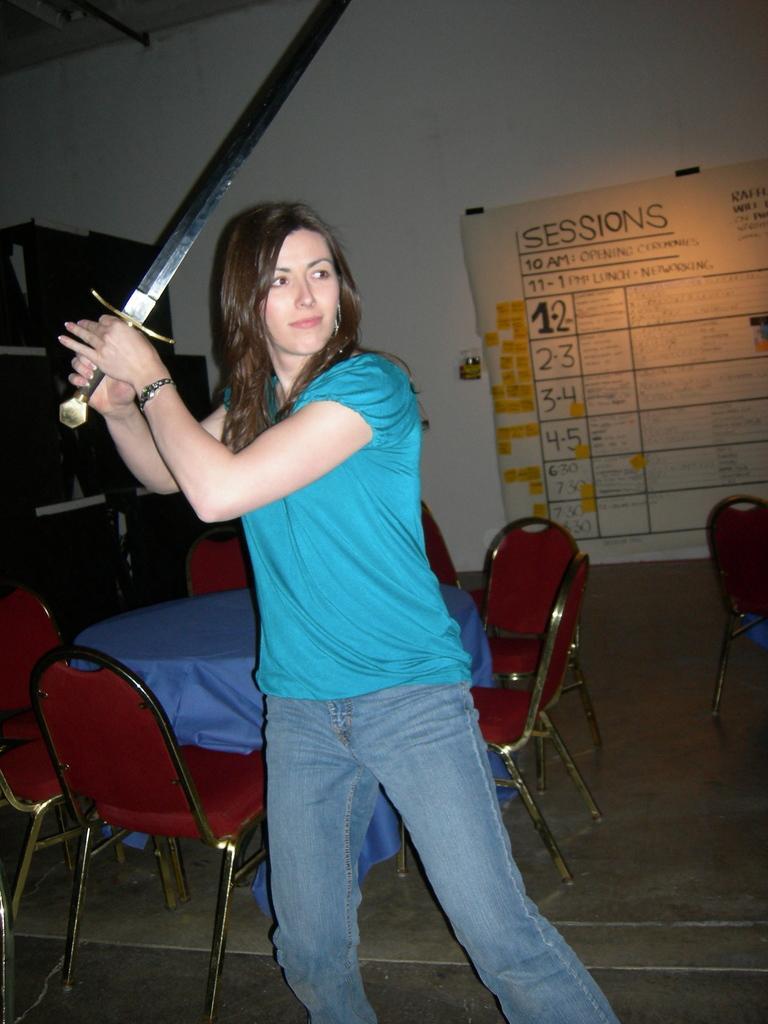Could you give a brief overview of what you see in this image? In this image we see a woman wearing blue t shirt is holding a sword in her hands. In the background we can see a chairs and table, chart on the wall. 